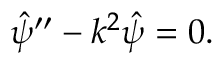<formula> <loc_0><loc_0><loc_500><loc_500>\begin{array} { r } { \hat { \psi } ^ { \prime \prime } - k ^ { 2 } \hat { \psi } = 0 . } \end{array}</formula> 